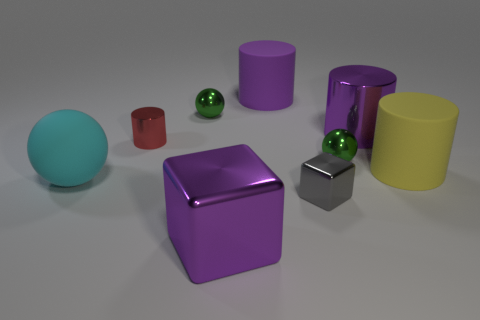Is the big purple matte thing the same shape as the red metal object?
Make the answer very short. Yes. There is a large shiny thing in front of the large metal cylinder; what number of large yellow matte objects are on the left side of it?
Ensure brevity in your answer.  0. What is the material of the other large purple object that is the same shape as the purple matte thing?
Make the answer very short. Metal. There is a big rubber cylinder to the left of the yellow matte cylinder; is its color the same as the large metal cylinder?
Give a very brief answer. Yes. Is the tiny gray object made of the same material as the ball in front of the yellow cylinder?
Provide a succinct answer. No. There is a purple object that is in front of the tiny metal cylinder; what shape is it?
Make the answer very short. Cube. How many other things are the same material as the cyan object?
Give a very brief answer. 2. The cyan object is what size?
Ensure brevity in your answer.  Large. How many other things are the same color as the small block?
Provide a short and direct response. 0. There is a shiny object that is both behind the small red shiny cylinder and to the right of the large purple block; what is its color?
Offer a terse response. Purple. 